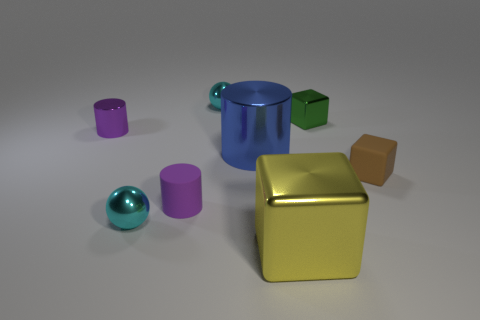Subtract all small green blocks. How many blocks are left? 2 Add 2 large blue spheres. How many objects exist? 10 Subtract 1 balls. How many balls are left? 1 Subtract all yellow blocks. How many blocks are left? 2 Subtract all spheres. How many objects are left? 6 Subtract all green cylinders. Subtract all yellow blocks. How many cylinders are left? 3 Subtract all cyan balls. How many purple cylinders are left? 2 Subtract all tiny purple cylinders. Subtract all blue things. How many objects are left? 5 Add 8 small shiny blocks. How many small shiny blocks are left? 9 Add 3 small brown matte things. How many small brown matte things exist? 4 